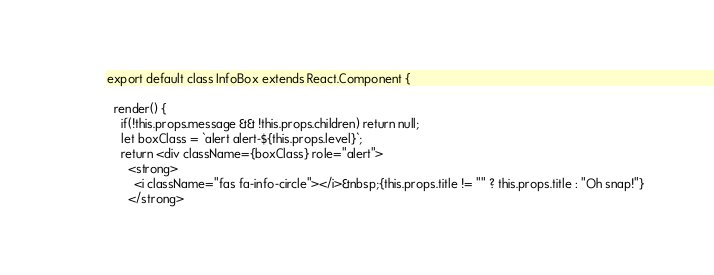Convert code to text. <code><loc_0><loc_0><loc_500><loc_500><_JavaScript_>export default class InfoBox extends React.Component {

  render() {
    if(!this.props.message && !this.props.children) return null;
    let boxClass = `alert alert-${this.props.level}`;
    return <div className={boxClass} role="alert">
      <strong>
        <i className="fas fa-info-circle"></i>&nbsp;{this.props.title != "" ? this.props.title : "Oh snap!"}
      </strong></code> 